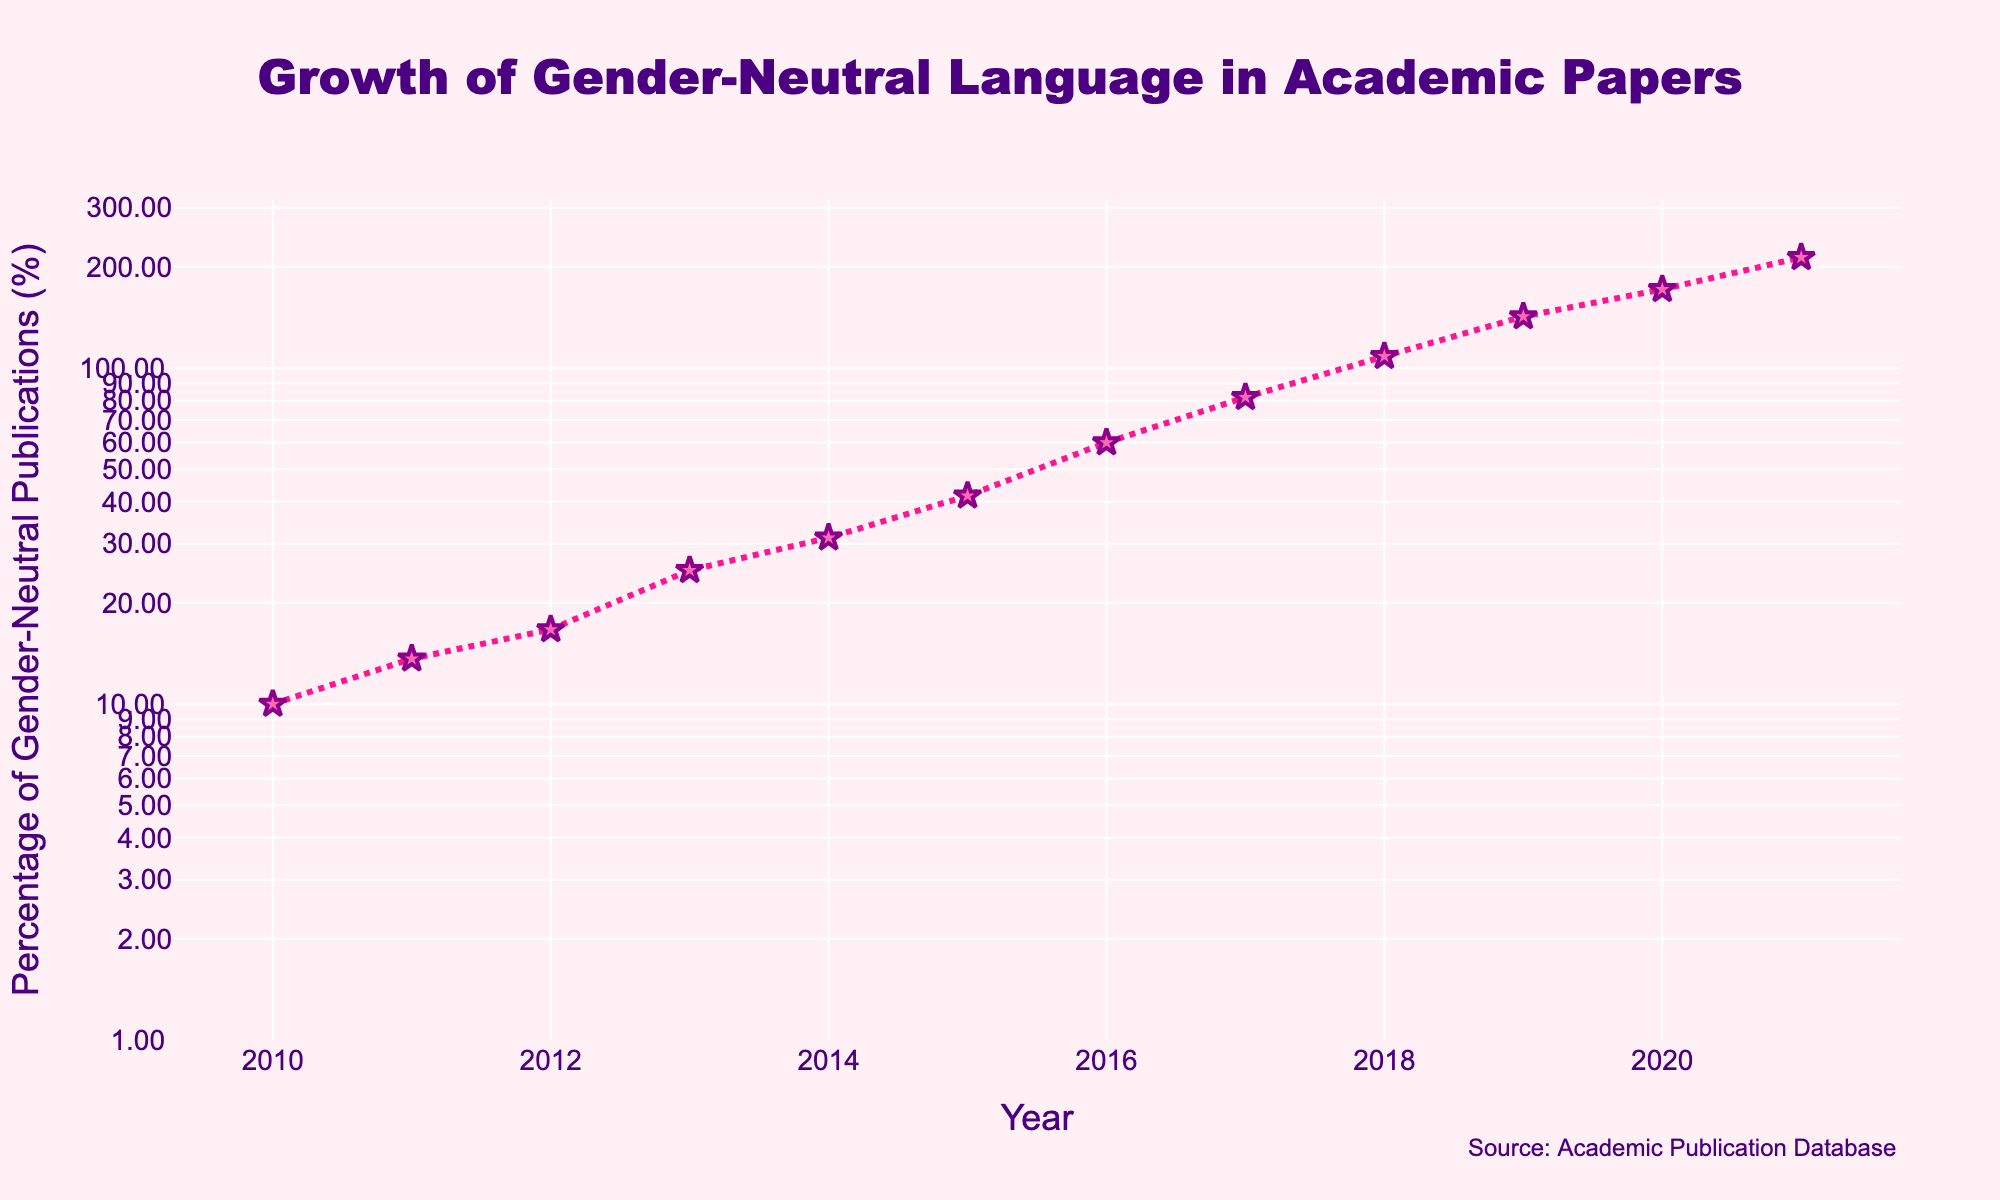What is the title of the plot? The title is usually located at the top of the figure and is designed to provide a quick summary of the data depicted. In this case, it reads "Growth of Gender-Neutral Language in Academic Papers".
Answer: Growth of Gender-Neutral Language in Academic Papers Which year shows the highest percentage of gender-neutral language usage? To find the highest percentage, identify the data point at the highest position along the y-axis. 2021 shows the highest percentage of gender-neutral language usage.
Answer: 2021 What is the percentage of gender-neutral publications in 2015? Locate the 2015 data point and read the corresponding y-value. The percentage of gender-neutral publications in 2015 is approximately 41.67%.
Answer: 41.67% Between which consecutive years is the most significant growth in percentage observed? To determine this, look for the steepest rise between consecutive points. The most significant growth occurs between 2016 and 2017.
Answer: 2016 to 2017 What is the range of the y-axis? The y-axis is set to a log scale, and the range can be deduced from the ticks and axis labels starting from the lowest value to the highest visible one. The range is approximately from 1 to 1000.
Answer: 1 to 1000 By how much did the percentage of gender-neutral publications increase from 2018 to 2021? Calculate the difference in percentages between these years. The percentage in 2021 is about 213.33%, and in 2018 is about 108.33%. The increase is 213.33% - 108.33% = 105%
Answer: 105% Which year showed a more than two-fold increase from the previous year? Look for a year where the percentage more than doubled compared to the previous year. From 2014 to 2015, the percentage increases from about 31.25% to 41.67%, which is not more than two-fold. The correct year is 2017 with an increase from 60% to 81.82%.
Answer: 2017 What color is used for the markers in the plot? The markers’ color can be visually identified. They are pink in color.
Answer: Pink What is the least percentage of gender-neutral publications throughout the years shown? Identify the lowest data point on the y-axis. In 2010, the percentage is the lowest at 10%.
Answer: 10% How many data points are plotted in the figure? Count the number of data points shown, which is equivalent to the number of years for which data is available. There are 12 data points.
Answer: 12 